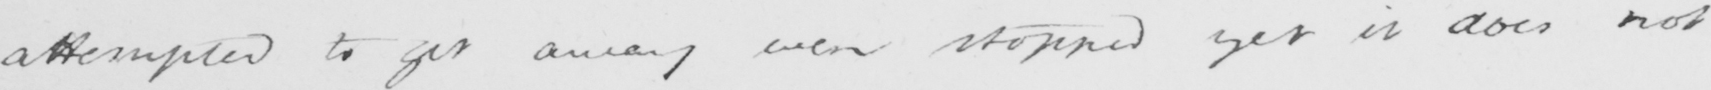What does this handwritten line say? attempted to get away were stopped yet it does not 